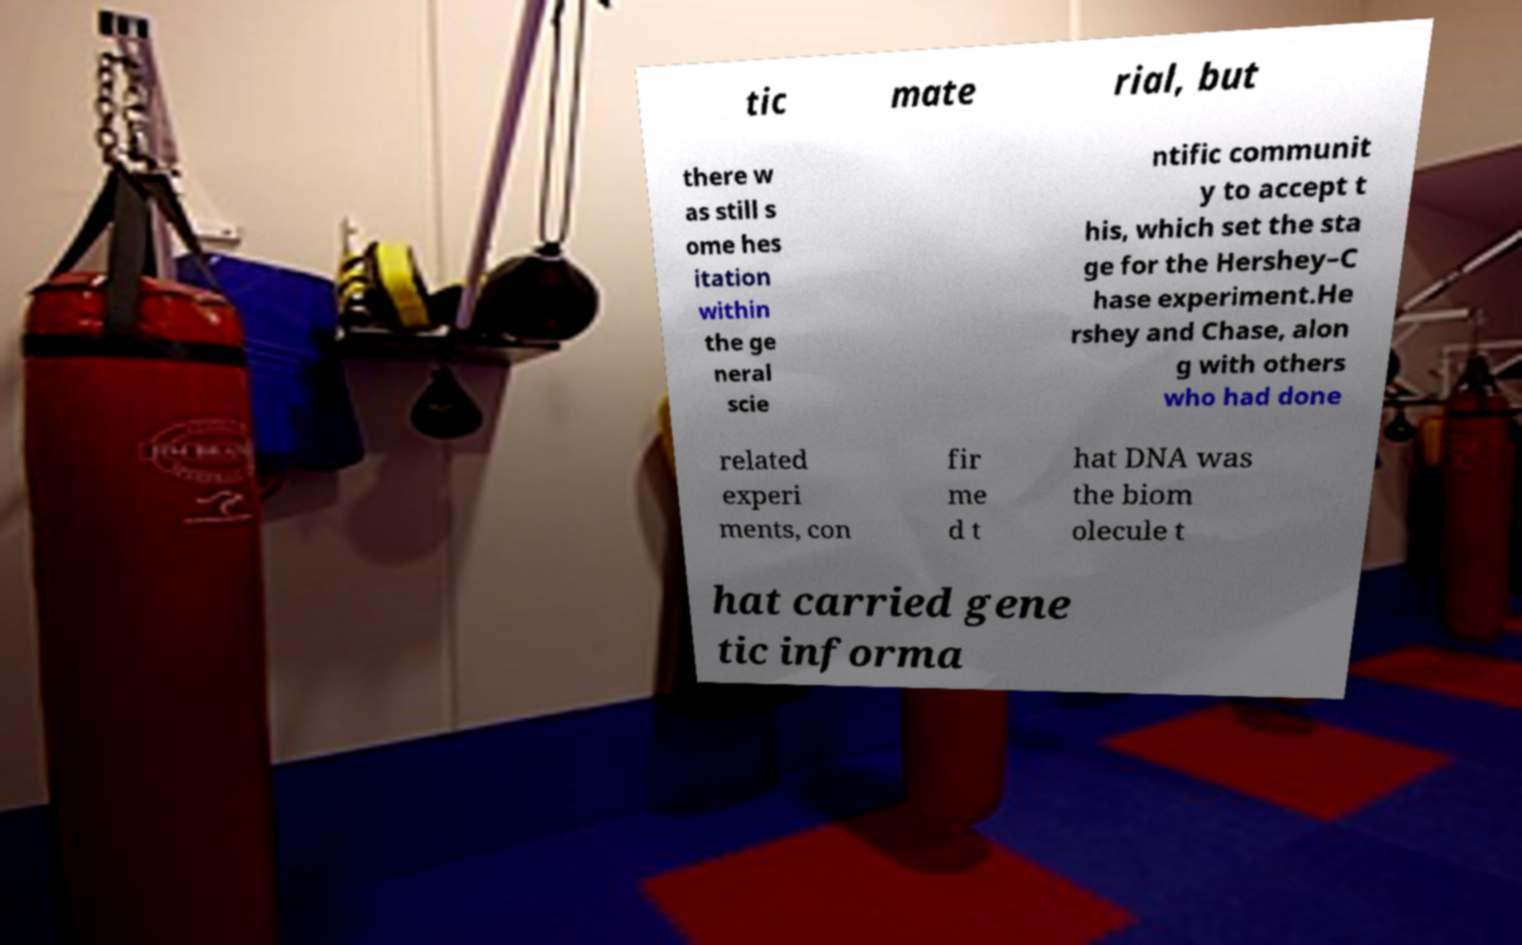Could you extract and type out the text from this image? tic mate rial, but there w as still s ome hes itation within the ge neral scie ntific communit y to accept t his, which set the sta ge for the Hershey–C hase experiment.He rshey and Chase, alon g with others who had done related experi ments, con fir me d t hat DNA was the biom olecule t hat carried gene tic informa 